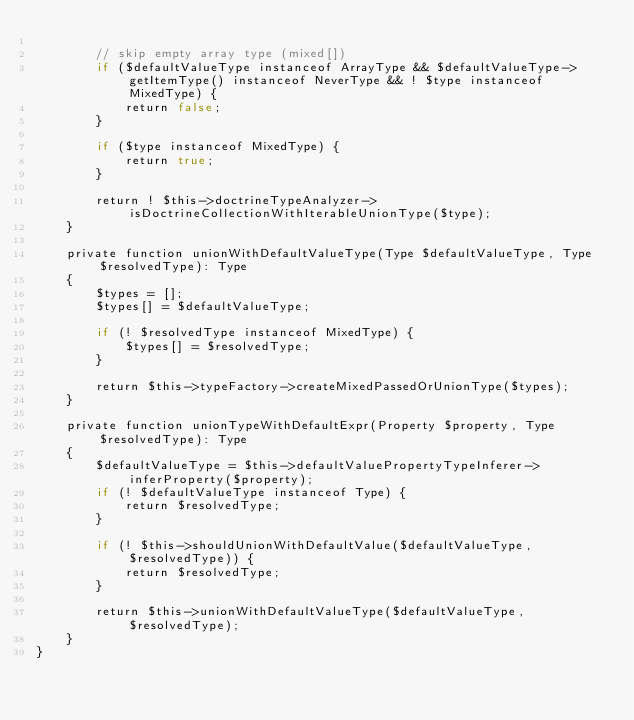Convert code to text. <code><loc_0><loc_0><loc_500><loc_500><_PHP_>
        // skip empty array type (mixed[])
        if ($defaultValueType instanceof ArrayType && $defaultValueType->getItemType() instanceof NeverType && ! $type instanceof MixedType) {
            return false;
        }

        if ($type instanceof MixedType) {
            return true;
        }

        return ! $this->doctrineTypeAnalyzer->isDoctrineCollectionWithIterableUnionType($type);
    }

    private function unionWithDefaultValueType(Type $defaultValueType, Type $resolvedType): Type
    {
        $types = [];
        $types[] = $defaultValueType;

        if (! $resolvedType instanceof MixedType) {
            $types[] = $resolvedType;
        }

        return $this->typeFactory->createMixedPassedOrUnionType($types);
    }

    private function unionTypeWithDefaultExpr(Property $property, Type $resolvedType): Type
    {
        $defaultValueType = $this->defaultValuePropertyTypeInferer->inferProperty($property);
        if (! $defaultValueType instanceof Type) {
            return $resolvedType;
        }

        if (! $this->shouldUnionWithDefaultValue($defaultValueType, $resolvedType)) {
            return $resolvedType;
        }

        return $this->unionWithDefaultValueType($defaultValueType, $resolvedType);
    }
}
</code> 